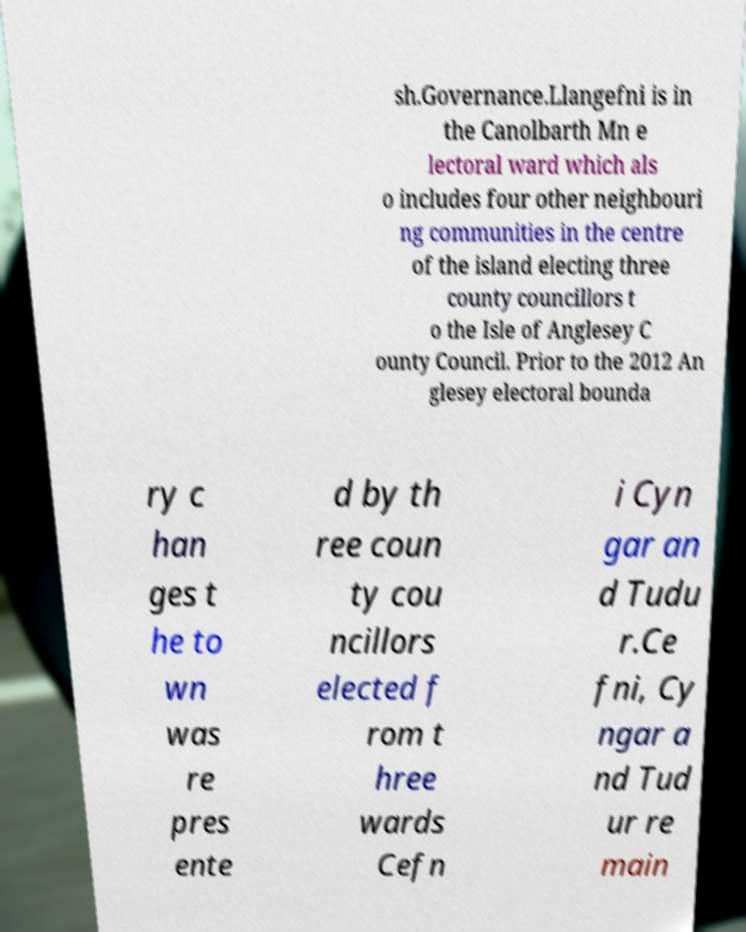Please read and relay the text visible in this image. What does it say? sh.Governance.Llangefni is in the Canolbarth Mn e lectoral ward which als o includes four other neighbouri ng communities in the centre of the island electing three county councillors t o the Isle of Anglesey C ounty Council. Prior to the 2012 An glesey electoral bounda ry c han ges t he to wn was re pres ente d by th ree coun ty cou ncillors elected f rom t hree wards Cefn i Cyn gar an d Tudu r.Ce fni, Cy ngar a nd Tud ur re main 